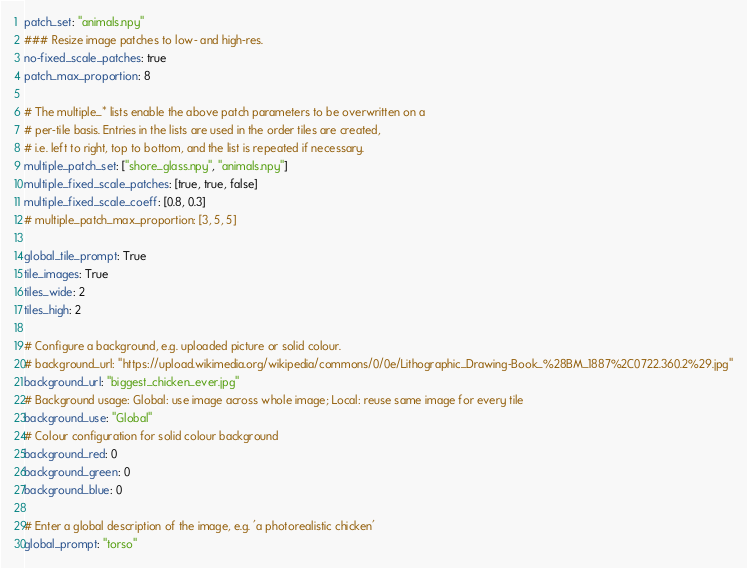<code> <loc_0><loc_0><loc_500><loc_500><_YAML_>patch_set: "animals.npy"
### Resize image patches to low- and high-res.
no-fixed_scale_patches: true
patch_max_proportion: 8

# The multiple_* lists enable the above patch parameters to be overwritten on a
# per-tile basis. Entries in the lists are used in the order tiles are created,
# i.e. left to right, top to bottom, and the list is repeated if necessary.
multiple_patch_set: ["shore_glass.npy", "animals.npy"]
multiple_fixed_scale_patches: [true, true, false]
multiple_fixed_scale_coeff: [0.8, 0.3]
# multiple_patch_max_proportion: [3, 5, 5]

global_tile_prompt: True
tile_images: True
tiles_wide: 2
tiles_high: 2

# Configure a background, e.g. uploaded picture or solid colour.
# background_url: "https://upload.wikimedia.org/wikipedia/commons/0/0e/Lithographic_Drawing-Book_%28BM_1887%2C0722.360.2%29.jpg"
background_url: "biggest_chicken_ever.jpg"
# Background usage: Global: use image across whole image; Local: reuse same image for every tile
background_use: "Global"
# Colour configuration for solid colour background
background_red: 0
background_green: 0
background_blue: 0

# Enter a global description of the image, e.g. 'a photorealistic chicken'
global_prompt: "torso"
</code> 